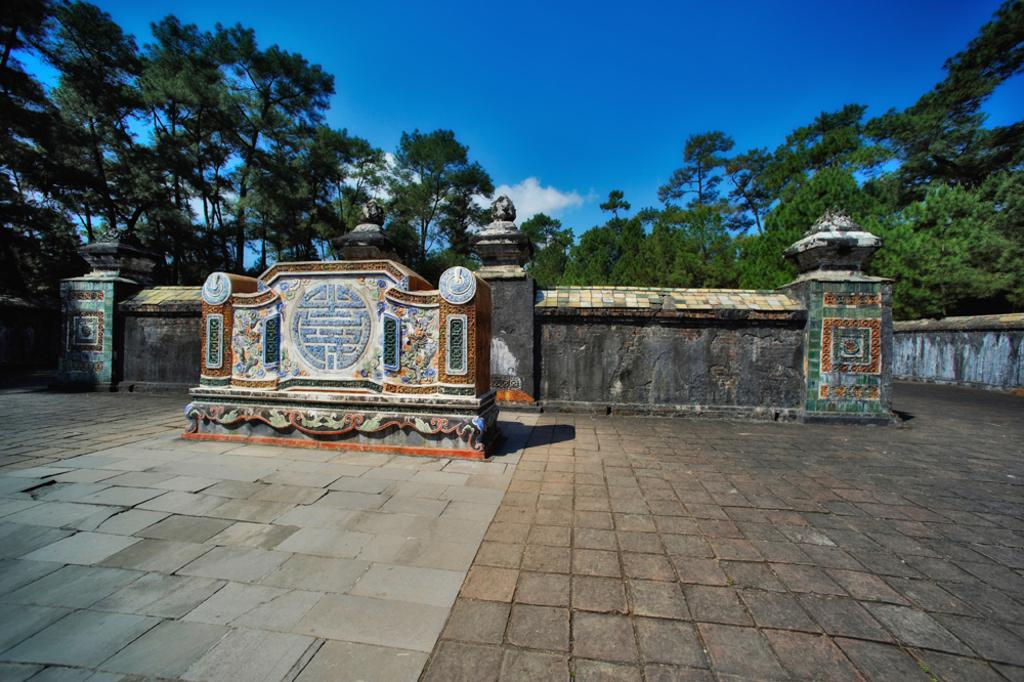What type of structures are in the foreground of the image? There are constructions made of stones in the foreground. What material are the constructions made of? The constructions are made of stones. What is the surface beneath the constructions? There is a stone surface at the bottom. What can be seen in the middle of the image? There are trees in the middle of the image. What is visible at the top of the image? The sky is visible at the top of the image. What type of hen is sitting on the owner's lap in the image? There is no hen or owner present in the image; it features stone constructions, trees, and a sky. 